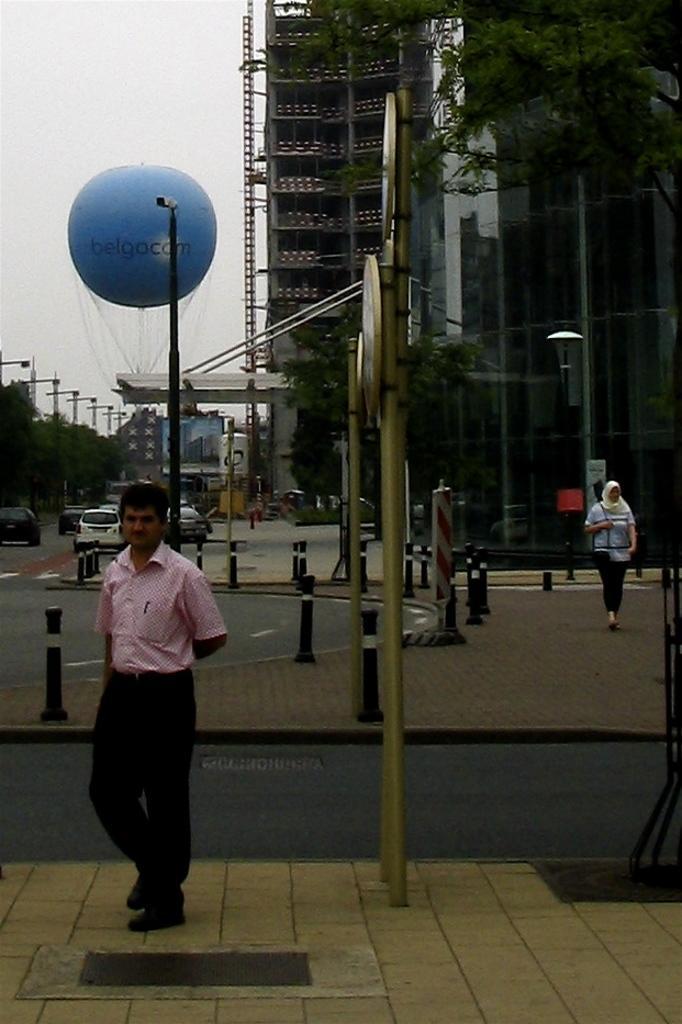Describe this image in one or two sentences. In this image I can see a group of people, boards, light poles, trees and fleets of vehicles on the road. In the background I can see buildings, metal rods, balloon and the sky. This image is taken may be on the road. 